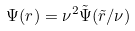<formula> <loc_0><loc_0><loc_500><loc_500>\Psi ( r ) = \nu ^ { 2 } \tilde { \Psi } ( \tilde { r } / \nu )</formula> 